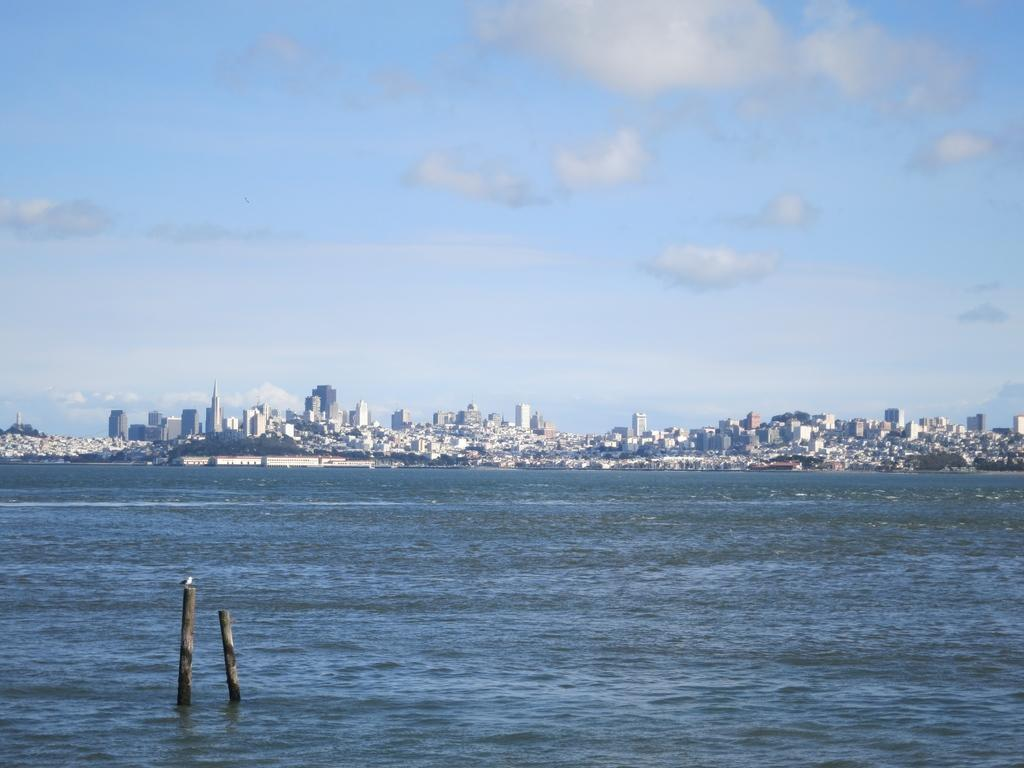What is present in the image that is not solid? There is water visible in the image. What type of objects can be seen in the image that are made of wood? There are two wooden poles in the image. What can be seen in the distance in the image? There are buildings in the background of the image. What is visible in the sky in the image? The sky is visible in the background of the image. What type of toothpaste is being used in the image? There is no toothpaste present in the image. What is the purpose of the meeting taking place in the image? There is no meeting present in the image. 